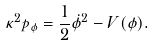<formula> <loc_0><loc_0><loc_500><loc_500>\kappa ^ { 2 } p _ { \phi } = \frac { 1 } { 2 } \dot { \phi } ^ { 2 } - V ( \phi ) .</formula> 